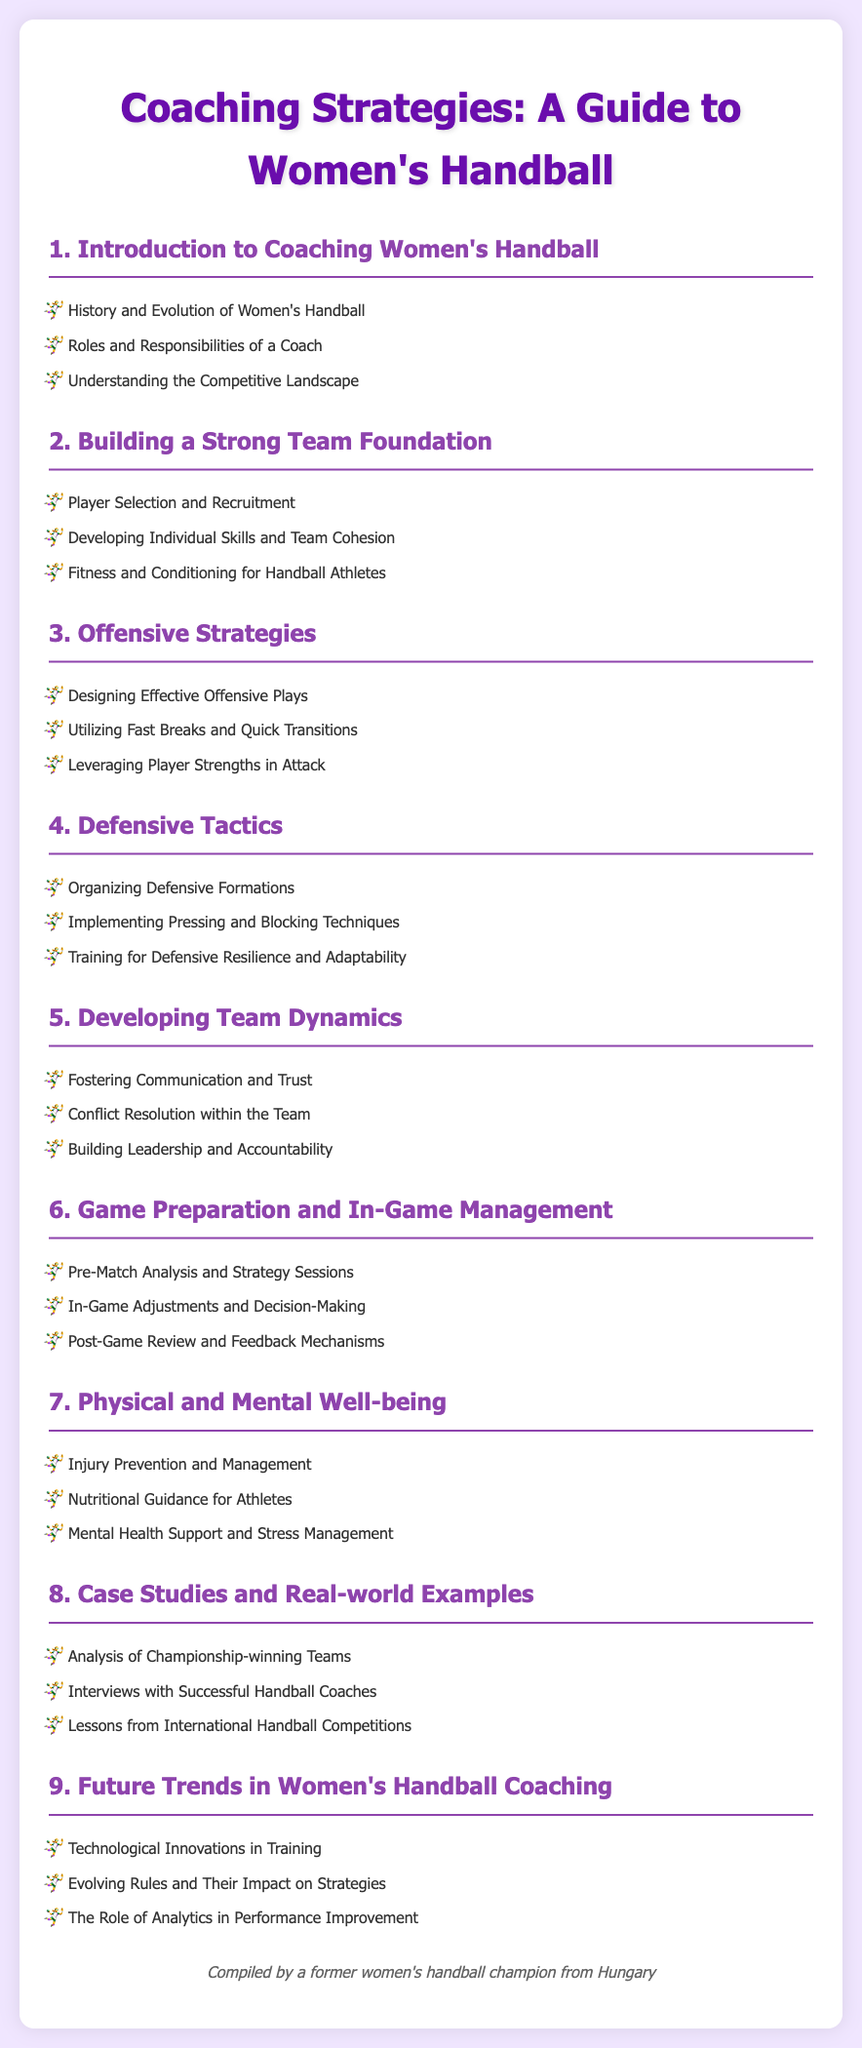what is the title of the document? The title is provided in the `<title>` tag and the heading at the top of the document, which is "Coaching Strategies: A Guide to Women's Handball."
Answer: Coaching Strategies: A Guide to Women's Handball how many sections are there in the document? The sections are numbered from 1 to 9, indicating a total of 9 sections.
Answer: 9 what is discussed in section 3? Section 3 is titled "Offensive Strategies" and contains three topics related to offense in handball.
Answer: Offensive Strategies which section covers injury prevention? Injury prevention is included in section 7, which is titled "Physical and Mental Well-being."
Answer: Physical and Mental Well-being what is the focus of section 6? Section 6 is specifically focused on game preparation and in-game management strategies.
Answer: Game Preparation and In-Game Management who compiled the document? The document notes "Compiled by a former women's handball champion from Hungary" as the author.
Answer: A former women's handball champion from Hungary what type of guidance is mentioned in section 7? Section 7 includes "Nutritional Guidance for Athletes" as one of its topics.
Answer: Nutritional Guidance for Athletes what is the last topic in section 9? The last topic listed in section 9 is "The Role of Analytics in Performance Improvement."
Answer: The Role of Analytics in Performance Improvement 